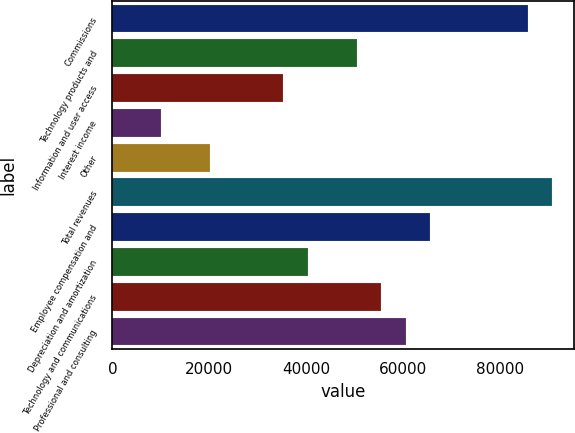Convert chart. <chart><loc_0><loc_0><loc_500><loc_500><bar_chart><fcel>Commissions<fcel>Technology products and<fcel>Information and user access<fcel>Interest income<fcel>Other<fcel>Total revenues<fcel>Employee compensation and<fcel>Depreciation and amortization<fcel>Technology and communications<fcel>Professional and consulting<nl><fcel>85657.6<fcel>50387<fcel>35271.1<fcel>10077.8<fcel>20155.1<fcel>90696.2<fcel>65503<fcel>40309.7<fcel>55425.7<fcel>60464.3<nl></chart> 